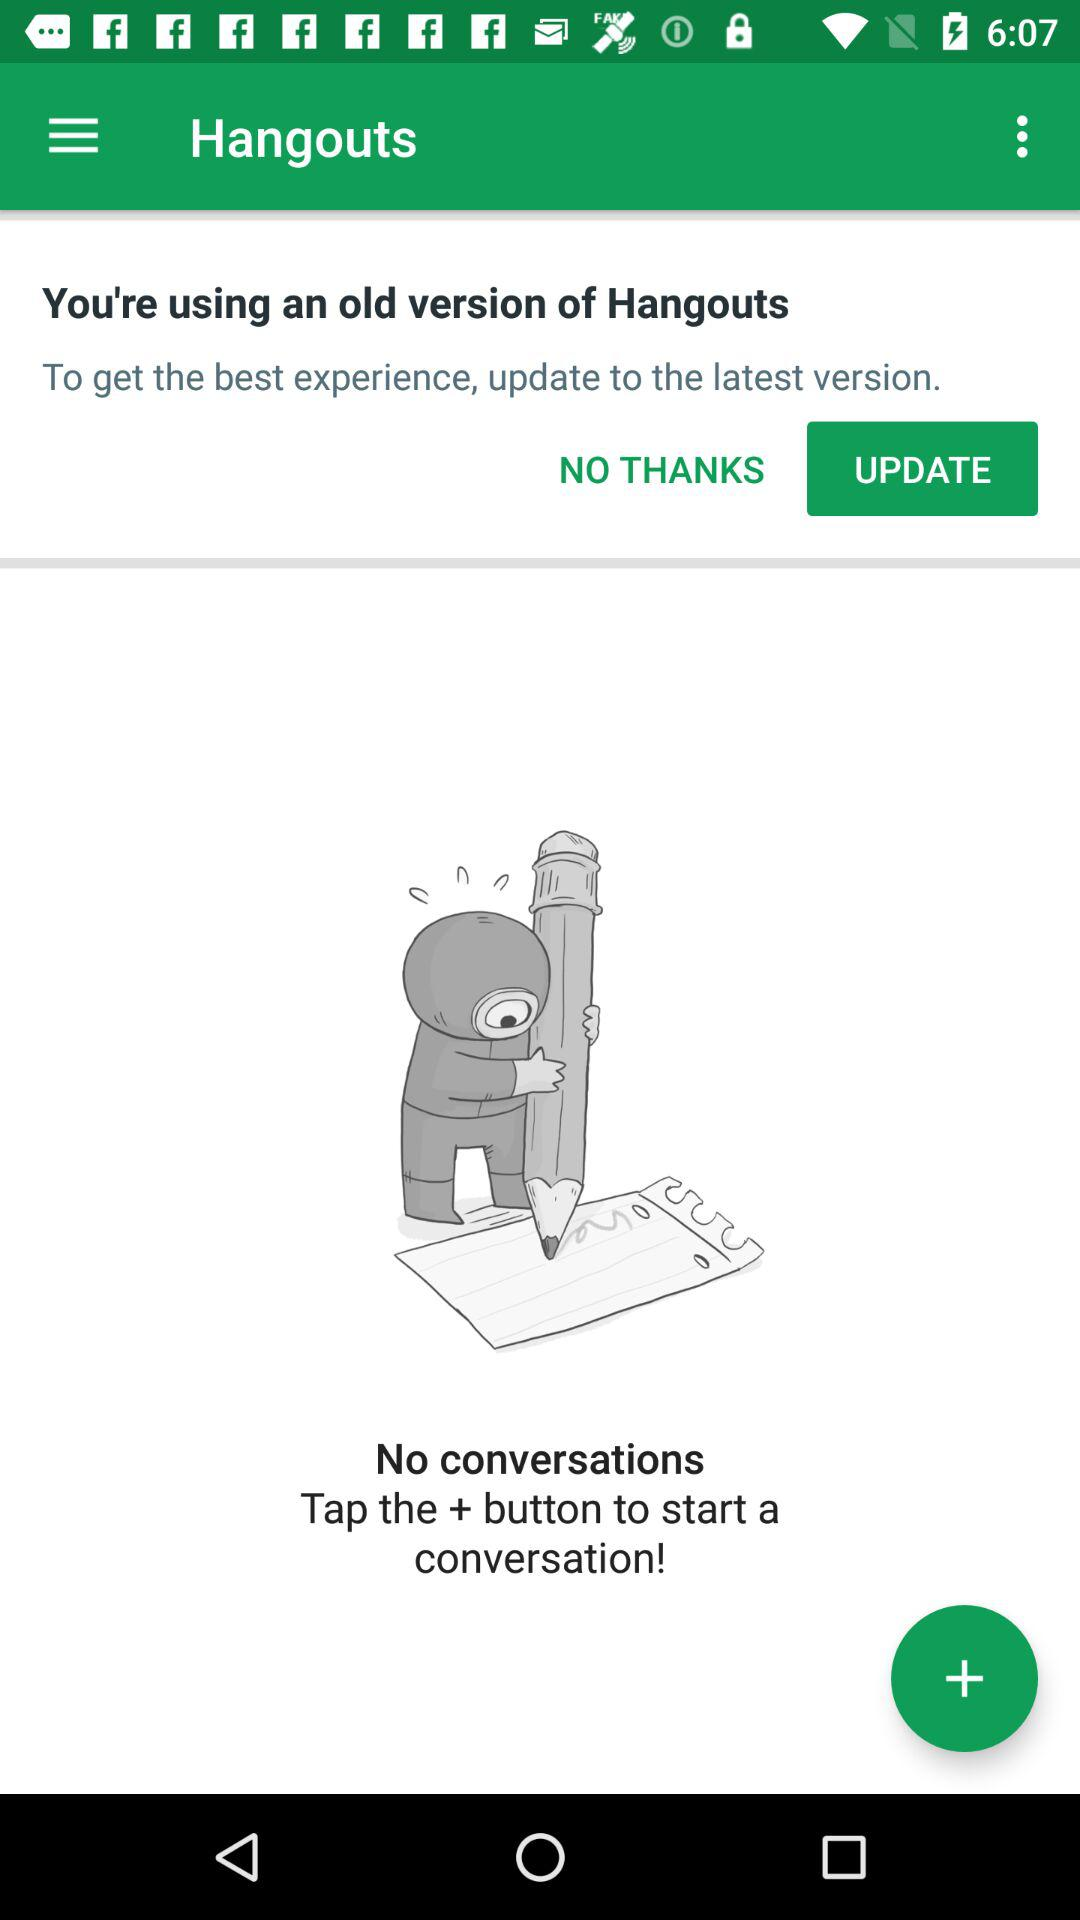What is the app name? The app name is "Hangouts". 